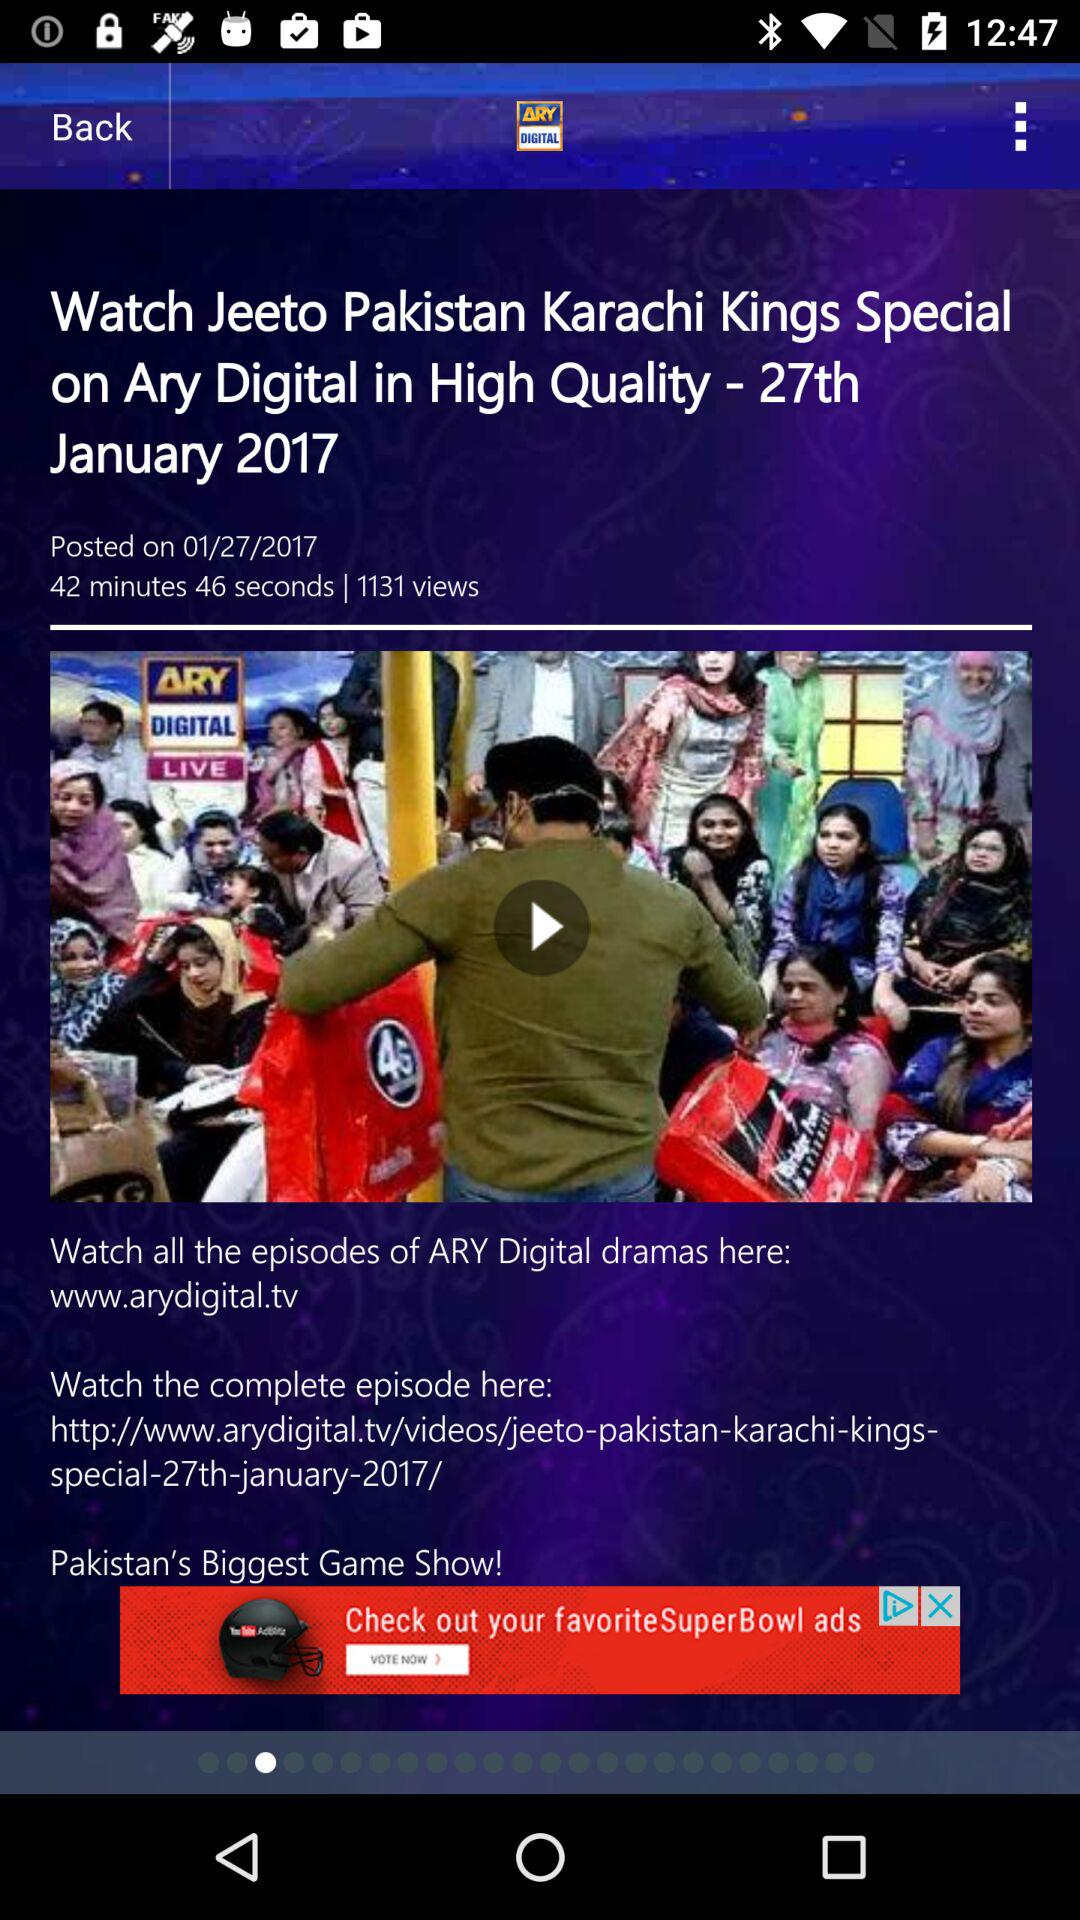How many views are there? There are 1131 views. 